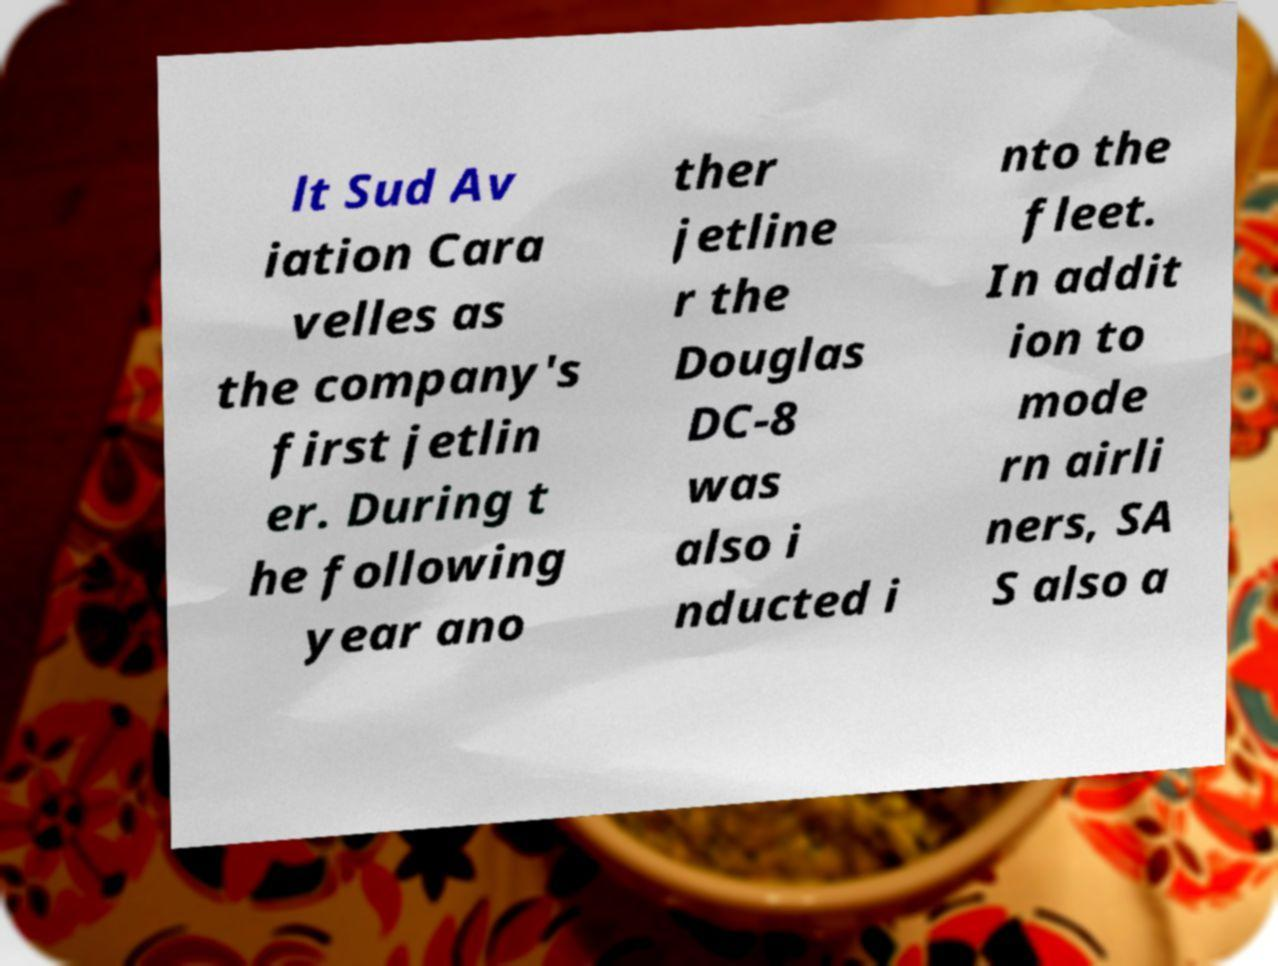I need the written content from this picture converted into text. Can you do that? lt Sud Av iation Cara velles as the company's first jetlin er. During t he following year ano ther jetline r the Douglas DC-8 was also i nducted i nto the fleet. In addit ion to mode rn airli ners, SA S also a 